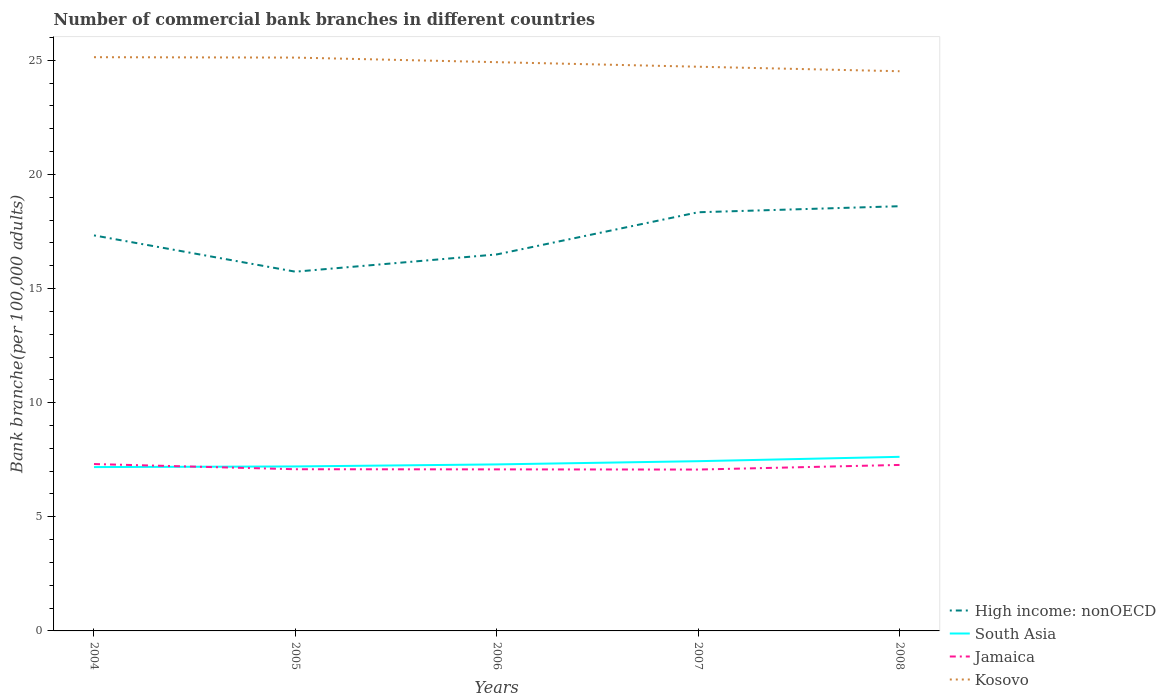Does the line corresponding to Kosovo intersect with the line corresponding to Jamaica?
Offer a terse response. No. Is the number of lines equal to the number of legend labels?
Keep it short and to the point. Yes. Across all years, what is the maximum number of commercial bank branches in High income: nonOECD?
Your answer should be very brief. 15.74. What is the total number of commercial bank branches in South Asia in the graph?
Your answer should be very brief. -0.09. What is the difference between the highest and the second highest number of commercial bank branches in Jamaica?
Keep it short and to the point. 0.24. Is the number of commercial bank branches in Jamaica strictly greater than the number of commercial bank branches in Kosovo over the years?
Provide a succinct answer. Yes. How many lines are there?
Keep it short and to the point. 4. How many years are there in the graph?
Offer a terse response. 5. Does the graph contain any zero values?
Your answer should be compact. No. How many legend labels are there?
Offer a terse response. 4. How are the legend labels stacked?
Ensure brevity in your answer.  Vertical. What is the title of the graph?
Offer a very short reply. Number of commercial bank branches in different countries. Does "Sudan" appear as one of the legend labels in the graph?
Offer a very short reply. No. What is the label or title of the X-axis?
Make the answer very short. Years. What is the label or title of the Y-axis?
Provide a short and direct response. Bank branche(per 100,0 adults). What is the Bank branche(per 100,000 adults) in High income: nonOECD in 2004?
Give a very brief answer. 17.33. What is the Bank branche(per 100,000 adults) in South Asia in 2004?
Offer a very short reply. 7.18. What is the Bank branche(per 100,000 adults) in Jamaica in 2004?
Your answer should be compact. 7.31. What is the Bank branche(per 100,000 adults) in Kosovo in 2004?
Your response must be concise. 25.14. What is the Bank branche(per 100,000 adults) in High income: nonOECD in 2005?
Keep it short and to the point. 15.74. What is the Bank branche(per 100,000 adults) of South Asia in 2005?
Offer a very short reply. 7.21. What is the Bank branche(per 100,000 adults) in Jamaica in 2005?
Make the answer very short. 7.08. What is the Bank branche(per 100,000 adults) of Kosovo in 2005?
Your answer should be compact. 25.12. What is the Bank branche(per 100,000 adults) in High income: nonOECD in 2006?
Ensure brevity in your answer.  16.5. What is the Bank branche(per 100,000 adults) in South Asia in 2006?
Provide a succinct answer. 7.3. What is the Bank branche(per 100,000 adults) in Jamaica in 2006?
Offer a terse response. 7.08. What is the Bank branche(per 100,000 adults) of Kosovo in 2006?
Make the answer very short. 24.92. What is the Bank branche(per 100,000 adults) in High income: nonOECD in 2007?
Keep it short and to the point. 18.34. What is the Bank branche(per 100,000 adults) of South Asia in 2007?
Provide a short and direct response. 7.44. What is the Bank branche(per 100,000 adults) in Jamaica in 2007?
Ensure brevity in your answer.  7.07. What is the Bank branche(per 100,000 adults) in Kosovo in 2007?
Provide a short and direct response. 24.72. What is the Bank branche(per 100,000 adults) in High income: nonOECD in 2008?
Give a very brief answer. 18.61. What is the Bank branche(per 100,000 adults) in South Asia in 2008?
Your answer should be very brief. 7.63. What is the Bank branche(per 100,000 adults) of Jamaica in 2008?
Ensure brevity in your answer.  7.27. What is the Bank branche(per 100,000 adults) in Kosovo in 2008?
Your answer should be compact. 24.52. Across all years, what is the maximum Bank branche(per 100,000 adults) in High income: nonOECD?
Provide a succinct answer. 18.61. Across all years, what is the maximum Bank branche(per 100,000 adults) in South Asia?
Your response must be concise. 7.63. Across all years, what is the maximum Bank branche(per 100,000 adults) of Jamaica?
Provide a short and direct response. 7.31. Across all years, what is the maximum Bank branche(per 100,000 adults) of Kosovo?
Offer a terse response. 25.14. Across all years, what is the minimum Bank branche(per 100,000 adults) of High income: nonOECD?
Make the answer very short. 15.74. Across all years, what is the minimum Bank branche(per 100,000 adults) in South Asia?
Your response must be concise. 7.18. Across all years, what is the minimum Bank branche(per 100,000 adults) of Jamaica?
Ensure brevity in your answer.  7.07. Across all years, what is the minimum Bank branche(per 100,000 adults) of Kosovo?
Keep it short and to the point. 24.52. What is the total Bank branche(per 100,000 adults) of High income: nonOECD in the graph?
Your response must be concise. 86.52. What is the total Bank branche(per 100,000 adults) in South Asia in the graph?
Keep it short and to the point. 36.75. What is the total Bank branche(per 100,000 adults) in Jamaica in the graph?
Give a very brief answer. 35.82. What is the total Bank branche(per 100,000 adults) of Kosovo in the graph?
Your answer should be compact. 124.42. What is the difference between the Bank branche(per 100,000 adults) of High income: nonOECD in 2004 and that in 2005?
Give a very brief answer. 1.59. What is the difference between the Bank branche(per 100,000 adults) of South Asia in 2004 and that in 2005?
Ensure brevity in your answer.  -0.03. What is the difference between the Bank branche(per 100,000 adults) in Jamaica in 2004 and that in 2005?
Your answer should be compact. 0.23. What is the difference between the Bank branche(per 100,000 adults) in Kosovo in 2004 and that in 2005?
Give a very brief answer. 0.02. What is the difference between the Bank branche(per 100,000 adults) in High income: nonOECD in 2004 and that in 2006?
Offer a very short reply. 0.83. What is the difference between the Bank branche(per 100,000 adults) of South Asia in 2004 and that in 2006?
Offer a very short reply. -0.12. What is the difference between the Bank branche(per 100,000 adults) in Jamaica in 2004 and that in 2006?
Ensure brevity in your answer.  0.23. What is the difference between the Bank branche(per 100,000 adults) of Kosovo in 2004 and that in 2006?
Your response must be concise. 0.22. What is the difference between the Bank branche(per 100,000 adults) in High income: nonOECD in 2004 and that in 2007?
Offer a terse response. -1.01. What is the difference between the Bank branche(per 100,000 adults) of South Asia in 2004 and that in 2007?
Offer a very short reply. -0.26. What is the difference between the Bank branche(per 100,000 adults) in Jamaica in 2004 and that in 2007?
Make the answer very short. 0.24. What is the difference between the Bank branche(per 100,000 adults) in Kosovo in 2004 and that in 2007?
Ensure brevity in your answer.  0.42. What is the difference between the Bank branche(per 100,000 adults) of High income: nonOECD in 2004 and that in 2008?
Make the answer very short. -1.28. What is the difference between the Bank branche(per 100,000 adults) in South Asia in 2004 and that in 2008?
Keep it short and to the point. -0.45. What is the difference between the Bank branche(per 100,000 adults) in Jamaica in 2004 and that in 2008?
Offer a terse response. 0.04. What is the difference between the Bank branche(per 100,000 adults) in Kosovo in 2004 and that in 2008?
Ensure brevity in your answer.  0.62. What is the difference between the Bank branche(per 100,000 adults) of High income: nonOECD in 2005 and that in 2006?
Provide a succinct answer. -0.76. What is the difference between the Bank branche(per 100,000 adults) in South Asia in 2005 and that in 2006?
Give a very brief answer. -0.09. What is the difference between the Bank branche(per 100,000 adults) of Jamaica in 2005 and that in 2006?
Provide a succinct answer. 0.01. What is the difference between the Bank branche(per 100,000 adults) in Kosovo in 2005 and that in 2006?
Your response must be concise. 0.2. What is the difference between the Bank branche(per 100,000 adults) in High income: nonOECD in 2005 and that in 2007?
Offer a very short reply. -2.6. What is the difference between the Bank branche(per 100,000 adults) in South Asia in 2005 and that in 2007?
Offer a terse response. -0.23. What is the difference between the Bank branche(per 100,000 adults) of Jamaica in 2005 and that in 2007?
Make the answer very short. 0.01. What is the difference between the Bank branche(per 100,000 adults) in Kosovo in 2005 and that in 2007?
Keep it short and to the point. 0.4. What is the difference between the Bank branche(per 100,000 adults) of High income: nonOECD in 2005 and that in 2008?
Provide a short and direct response. -2.87. What is the difference between the Bank branche(per 100,000 adults) of South Asia in 2005 and that in 2008?
Ensure brevity in your answer.  -0.42. What is the difference between the Bank branche(per 100,000 adults) of Jamaica in 2005 and that in 2008?
Your answer should be compact. -0.19. What is the difference between the Bank branche(per 100,000 adults) in Kosovo in 2005 and that in 2008?
Your answer should be compact. 0.6. What is the difference between the Bank branche(per 100,000 adults) in High income: nonOECD in 2006 and that in 2007?
Your response must be concise. -1.85. What is the difference between the Bank branche(per 100,000 adults) in South Asia in 2006 and that in 2007?
Your answer should be compact. -0.14. What is the difference between the Bank branche(per 100,000 adults) of Jamaica in 2006 and that in 2007?
Ensure brevity in your answer.  0.01. What is the difference between the Bank branche(per 100,000 adults) in Kosovo in 2006 and that in 2007?
Make the answer very short. 0.2. What is the difference between the Bank branche(per 100,000 adults) of High income: nonOECD in 2006 and that in 2008?
Offer a terse response. -2.11. What is the difference between the Bank branche(per 100,000 adults) in South Asia in 2006 and that in 2008?
Your answer should be compact. -0.33. What is the difference between the Bank branche(per 100,000 adults) in Jamaica in 2006 and that in 2008?
Ensure brevity in your answer.  -0.19. What is the difference between the Bank branche(per 100,000 adults) in Kosovo in 2006 and that in 2008?
Your answer should be compact. 0.4. What is the difference between the Bank branche(per 100,000 adults) in High income: nonOECD in 2007 and that in 2008?
Make the answer very short. -0.26. What is the difference between the Bank branche(per 100,000 adults) of South Asia in 2007 and that in 2008?
Offer a terse response. -0.19. What is the difference between the Bank branche(per 100,000 adults) of Jamaica in 2007 and that in 2008?
Your answer should be very brief. -0.2. What is the difference between the Bank branche(per 100,000 adults) of Kosovo in 2007 and that in 2008?
Your answer should be very brief. 0.2. What is the difference between the Bank branche(per 100,000 adults) of High income: nonOECD in 2004 and the Bank branche(per 100,000 adults) of South Asia in 2005?
Provide a succinct answer. 10.12. What is the difference between the Bank branche(per 100,000 adults) in High income: nonOECD in 2004 and the Bank branche(per 100,000 adults) in Jamaica in 2005?
Your answer should be compact. 10.25. What is the difference between the Bank branche(per 100,000 adults) of High income: nonOECD in 2004 and the Bank branche(per 100,000 adults) of Kosovo in 2005?
Keep it short and to the point. -7.79. What is the difference between the Bank branche(per 100,000 adults) in South Asia in 2004 and the Bank branche(per 100,000 adults) in Jamaica in 2005?
Make the answer very short. 0.09. What is the difference between the Bank branche(per 100,000 adults) of South Asia in 2004 and the Bank branche(per 100,000 adults) of Kosovo in 2005?
Keep it short and to the point. -17.94. What is the difference between the Bank branche(per 100,000 adults) of Jamaica in 2004 and the Bank branche(per 100,000 adults) of Kosovo in 2005?
Provide a short and direct response. -17.81. What is the difference between the Bank branche(per 100,000 adults) in High income: nonOECD in 2004 and the Bank branche(per 100,000 adults) in South Asia in 2006?
Offer a terse response. 10.03. What is the difference between the Bank branche(per 100,000 adults) in High income: nonOECD in 2004 and the Bank branche(per 100,000 adults) in Jamaica in 2006?
Offer a very short reply. 10.25. What is the difference between the Bank branche(per 100,000 adults) in High income: nonOECD in 2004 and the Bank branche(per 100,000 adults) in Kosovo in 2006?
Provide a succinct answer. -7.59. What is the difference between the Bank branche(per 100,000 adults) of South Asia in 2004 and the Bank branche(per 100,000 adults) of Jamaica in 2006?
Ensure brevity in your answer.  0.1. What is the difference between the Bank branche(per 100,000 adults) of South Asia in 2004 and the Bank branche(per 100,000 adults) of Kosovo in 2006?
Provide a succinct answer. -17.74. What is the difference between the Bank branche(per 100,000 adults) of Jamaica in 2004 and the Bank branche(per 100,000 adults) of Kosovo in 2006?
Provide a short and direct response. -17.61. What is the difference between the Bank branche(per 100,000 adults) in High income: nonOECD in 2004 and the Bank branche(per 100,000 adults) in South Asia in 2007?
Your answer should be compact. 9.89. What is the difference between the Bank branche(per 100,000 adults) in High income: nonOECD in 2004 and the Bank branche(per 100,000 adults) in Jamaica in 2007?
Offer a very short reply. 10.26. What is the difference between the Bank branche(per 100,000 adults) in High income: nonOECD in 2004 and the Bank branche(per 100,000 adults) in Kosovo in 2007?
Your response must be concise. -7.39. What is the difference between the Bank branche(per 100,000 adults) in South Asia in 2004 and the Bank branche(per 100,000 adults) in Jamaica in 2007?
Your answer should be compact. 0.11. What is the difference between the Bank branche(per 100,000 adults) of South Asia in 2004 and the Bank branche(per 100,000 adults) of Kosovo in 2007?
Provide a short and direct response. -17.54. What is the difference between the Bank branche(per 100,000 adults) of Jamaica in 2004 and the Bank branche(per 100,000 adults) of Kosovo in 2007?
Provide a succinct answer. -17.41. What is the difference between the Bank branche(per 100,000 adults) of High income: nonOECD in 2004 and the Bank branche(per 100,000 adults) of South Asia in 2008?
Your response must be concise. 9.7. What is the difference between the Bank branche(per 100,000 adults) in High income: nonOECD in 2004 and the Bank branche(per 100,000 adults) in Jamaica in 2008?
Provide a succinct answer. 10.06. What is the difference between the Bank branche(per 100,000 adults) in High income: nonOECD in 2004 and the Bank branche(per 100,000 adults) in Kosovo in 2008?
Your answer should be very brief. -7.19. What is the difference between the Bank branche(per 100,000 adults) in South Asia in 2004 and the Bank branche(per 100,000 adults) in Jamaica in 2008?
Give a very brief answer. -0.09. What is the difference between the Bank branche(per 100,000 adults) in South Asia in 2004 and the Bank branche(per 100,000 adults) in Kosovo in 2008?
Your answer should be compact. -17.34. What is the difference between the Bank branche(per 100,000 adults) of Jamaica in 2004 and the Bank branche(per 100,000 adults) of Kosovo in 2008?
Give a very brief answer. -17.21. What is the difference between the Bank branche(per 100,000 adults) of High income: nonOECD in 2005 and the Bank branche(per 100,000 adults) of South Asia in 2006?
Offer a very short reply. 8.44. What is the difference between the Bank branche(per 100,000 adults) in High income: nonOECD in 2005 and the Bank branche(per 100,000 adults) in Jamaica in 2006?
Keep it short and to the point. 8.66. What is the difference between the Bank branche(per 100,000 adults) of High income: nonOECD in 2005 and the Bank branche(per 100,000 adults) of Kosovo in 2006?
Offer a very short reply. -9.18. What is the difference between the Bank branche(per 100,000 adults) of South Asia in 2005 and the Bank branche(per 100,000 adults) of Jamaica in 2006?
Your answer should be very brief. 0.13. What is the difference between the Bank branche(per 100,000 adults) in South Asia in 2005 and the Bank branche(per 100,000 adults) in Kosovo in 2006?
Ensure brevity in your answer.  -17.71. What is the difference between the Bank branche(per 100,000 adults) of Jamaica in 2005 and the Bank branche(per 100,000 adults) of Kosovo in 2006?
Your answer should be compact. -17.84. What is the difference between the Bank branche(per 100,000 adults) of High income: nonOECD in 2005 and the Bank branche(per 100,000 adults) of South Asia in 2007?
Offer a terse response. 8.3. What is the difference between the Bank branche(per 100,000 adults) in High income: nonOECD in 2005 and the Bank branche(per 100,000 adults) in Jamaica in 2007?
Your answer should be very brief. 8.67. What is the difference between the Bank branche(per 100,000 adults) of High income: nonOECD in 2005 and the Bank branche(per 100,000 adults) of Kosovo in 2007?
Keep it short and to the point. -8.98. What is the difference between the Bank branche(per 100,000 adults) of South Asia in 2005 and the Bank branche(per 100,000 adults) of Jamaica in 2007?
Keep it short and to the point. 0.14. What is the difference between the Bank branche(per 100,000 adults) of South Asia in 2005 and the Bank branche(per 100,000 adults) of Kosovo in 2007?
Give a very brief answer. -17.51. What is the difference between the Bank branche(per 100,000 adults) of Jamaica in 2005 and the Bank branche(per 100,000 adults) of Kosovo in 2007?
Ensure brevity in your answer.  -17.64. What is the difference between the Bank branche(per 100,000 adults) in High income: nonOECD in 2005 and the Bank branche(per 100,000 adults) in South Asia in 2008?
Your response must be concise. 8.11. What is the difference between the Bank branche(per 100,000 adults) in High income: nonOECD in 2005 and the Bank branche(per 100,000 adults) in Jamaica in 2008?
Offer a terse response. 8.47. What is the difference between the Bank branche(per 100,000 adults) in High income: nonOECD in 2005 and the Bank branche(per 100,000 adults) in Kosovo in 2008?
Give a very brief answer. -8.78. What is the difference between the Bank branche(per 100,000 adults) of South Asia in 2005 and the Bank branche(per 100,000 adults) of Jamaica in 2008?
Offer a very short reply. -0.07. What is the difference between the Bank branche(per 100,000 adults) of South Asia in 2005 and the Bank branche(per 100,000 adults) of Kosovo in 2008?
Give a very brief answer. -17.32. What is the difference between the Bank branche(per 100,000 adults) of Jamaica in 2005 and the Bank branche(per 100,000 adults) of Kosovo in 2008?
Your answer should be compact. -17.44. What is the difference between the Bank branche(per 100,000 adults) in High income: nonOECD in 2006 and the Bank branche(per 100,000 adults) in South Asia in 2007?
Your answer should be very brief. 9.06. What is the difference between the Bank branche(per 100,000 adults) in High income: nonOECD in 2006 and the Bank branche(per 100,000 adults) in Jamaica in 2007?
Provide a succinct answer. 9.43. What is the difference between the Bank branche(per 100,000 adults) of High income: nonOECD in 2006 and the Bank branche(per 100,000 adults) of Kosovo in 2007?
Your answer should be very brief. -8.22. What is the difference between the Bank branche(per 100,000 adults) in South Asia in 2006 and the Bank branche(per 100,000 adults) in Jamaica in 2007?
Your answer should be very brief. 0.23. What is the difference between the Bank branche(per 100,000 adults) in South Asia in 2006 and the Bank branche(per 100,000 adults) in Kosovo in 2007?
Provide a succinct answer. -17.42. What is the difference between the Bank branche(per 100,000 adults) of Jamaica in 2006 and the Bank branche(per 100,000 adults) of Kosovo in 2007?
Ensure brevity in your answer.  -17.64. What is the difference between the Bank branche(per 100,000 adults) of High income: nonOECD in 2006 and the Bank branche(per 100,000 adults) of South Asia in 2008?
Offer a terse response. 8.87. What is the difference between the Bank branche(per 100,000 adults) of High income: nonOECD in 2006 and the Bank branche(per 100,000 adults) of Jamaica in 2008?
Provide a short and direct response. 9.22. What is the difference between the Bank branche(per 100,000 adults) of High income: nonOECD in 2006 and the Bank branche(per 100,000 adults) of Kosovo in 2008?
Your answer should be compact. -8.03. What is the difference between the Bank branche(per 100,000 adults) in South Asia in 2006 and the Bank branche(per 100,000 adults) in Jamaica in 2008?
Ensure brevity in your answer.  0.02. What is the difference between the Bank branche(per 100,000 adults) of South Asia in 2006 and the Bank branche(per 100,000 adults) of Kosovo in 2008?
Offer a very short reply. -17.23. What is the difference between the Bank branche(per 100,000 adults) of Jamaica in 2006 and the Bank branche(per 100,000 adults) of Kosovo in 2008?
Your answer should be very brief. -17.44. What is the difference between the Bank branche(per 100,000 adults) of High income: nonOECD in 2007 and the Bank branche(per 100,000 adults) of South Asia in 2008?
Provide a short and direct response. 10.72. What is the difference between the Bank branche(per 100,000 adults) of High income: nonOECD in 2007 and the Bank branche(per 100,000 adults) of Jamaica in 2008?
Your answer should be very brief. 11.07. What is the difference between the Bank branche(per 100,000 adults) of High income: nonOECD in 2007 and the Bank branche(per 100,000 adults) of Kosovo in 2008?
Ensure brevity in your answer.  -6.18. What is the difference between the Bank branche(per 100,000 adults) of South Asia in 2007 and the Bank branche(per 100,000 adults) of Jamaica in 2008?
Ensure brevity in your answer.  0.16. What is the difference between the Bank branche(per 100,000 adults) of South Asia in 2007 and the Bank branche(per 100,000 adults) of Kosovo in 2008?
Provide a short and direct response. -17.09. What is the difference between the Bank branche(per 100,000 adults) of Jamaica in 2007 and the Bank branche(per 100,000 adults) of Kosovo in 2008?
Ensure brevity in your answer.  -17.45. What is the average Bank branche(per 100,000 adults) of High income: nonOECD per year?
Your response must be concise. 17.3. What is the average Bank branche(per 100,000 adults) of South Asia per year?
Ensure brevity in your answer.  7.35. What is the average Bank branche(per 100,000 adults) of Jamaica per year?
Offer a very short reply. 7.16. What is the average Bank branche(per 100,000 adults) of Kosovo per year?
Your answer should be compact. 24.88. In the year 2004, what is the difference between the Bank branche(per 100,000 adults) in High income: nonOECD and Bank branche(per 100,000 adults) in South Asia?
Provide a succinct answer. 10.15. In the year 2004, what is the difference between the Bank branche(per 100,000 adults) of High income: nonOECD and Bank branche(per 100,000 adults) of Jamaica?
Your answer should be compact. 10.02. In the year 2004, what is the difference between the Bank branche(per 100,000 adults) of High income: nonOECD and Bank branche(per 100,000 adults) of Kosovo?
Provide a short and direct response. -7.81. In the year 2004, what is the difference between the Bank branche(per 100,000 adults) of South Asia and Bank branche(per 100,000 adults) of Jamaica?
Ensure brevity in your answer.  -0.13. In the year 2004, what is the difference between the Bank branche(per 100,000 adults) in South Asia and Bank branche(per 100,000 adults) in Kosovo?
Provide a succinct answer. -17.96. In the year 2004, what is the difference between the Bank branche(per 100,000 adults) of Jamaica and Bank branche(per 100,000 adults) of Kosovo?
Ensure brevity in your answer.  -17.83. In the year 2005, what is the difference between the Bank branche(per 100,000 adults) in High income: nonOECD and Bank branche(per 100,000 adults) in South Asia?
Provide a short and direct response. 8.53. In the year 2005, what is the difference between the Bank branche(per 100,000 adults) of High income: nonOECD and Bank branche(per 100,000 adults) of Jamaica?
Your answer should be very brief. 8.66. In the year 2005, what is the difference between the Bank branche(per 100,000 adults) of High income: nonOECD and Bank branche(per 100,000 adults) of Kosovo?
Your answer should be compact. -9.38. In the year 2005, what is the difference between the Bank branche(per 100,000 adults) in South Asia and Bank branche(per 100,000 adults) in Jamaica?
Make the answer very short. 0.12. In the year 2005, what is the difference between the Bank branche(per 100,000 adults) in South Asia and Bank branche(per 100,000 adults) in Kosovo?
Your answer should be very brief. -17.91. In the year 2005, what is the difference between the Bank branche(per 100,000 adults) in Jamaica and Bank branche(per 100,000 adults) in Kosovo?
Offer a terse response. -18.04. In the year 2006, what is the difference between the Bank branche(per 100,000 adults) of High income: nonOECD and Bank branche(per 100,000 adults) of South Asia?
Offer a terse response. 9.2. In the year 2006, what is the difference between the Bank branche(per 100,000 adults) of High income: nonOECD and Bank branche(per 100,000 adults) of Jamaica?
Provide a short and direct response. 9.42. In the year 2006, what is the difference between the Bank branche(per 100,000 adults) of High income: nonOECD and Bank branche(per 100,000 adults) of Kosovo?
Make the answer very short. -8.42. In the year 2006, what is the difference between the Bank branche(per 100,000 adults) of South Asia and Bank branche(per 100,000 adults) of Jamaica?
Provide a succinct answer. 0.22. In the year 2006, what is the difference between the Bank branche(per 100,000 adults) in South Asia and Bank branche(per 100,000 adults) in Kosovo?
Make the answer very short. -17.62. In the year 2006, what is the difference between the Bank branche(per 100,000 adults) in Jamaica and Bank branche(per 100,000 adults) in Kosovo?
Ensure brevity in your answer.  -17.84. In the year 2007, what is the difference between the Bank branche(per 100,000 adults) of High income: nonOECD and Bank branche(per 100,000 adults) of South Asia?
Offer a very short reply. 10.91. In the year 2007, what is the difference between the Bank branche(per 100,000 adults) in High income: nonOECD and Bank branche(per 100,000 adults) in Jamaica?
Give a very brief answer. 11.27. In the year 2007, what is the difference between the Bank branche(per 100,000 adults) of High income: nonOECD and Bank branche(per 100,000 adults) of Kosovo?
Keep it short and to the point. -6.38. In the year 2007, what is the difference between the Bank branche(per 100,000 adults) in South Asia and Bank branche(per 100,000 adults) in Jamaica?
Offer a terse response. 0.37. In the year 2007, what is the difference between the Bank branche(per 100,000 adults) in South Asia and Bank branche(per 100,000 adults) in Kosovo?
Provide a short and direct response. -17.28. In the year 2007, what is the difference between the Bank branche(per 100,000 adults) of Jamaica and Bank branche(per 100,000 adults) of Kosovo?
Your response must be concise. -17.65. In the year 2008, what is the difference between the Bank branche(per 100,000 adults) of High income: nonOECD and Bank branche(per 100,000 adults) of South Asia?
Make the answer very short. 10.98. In the year 2008, what is the difference between the Bank branche(per 100,000 adults) of High income: nonOECD and Bank branche(per 100,000 adults) of Jamaica?
Give a very brief answer. 11.34. In the year 2008, what is the difference between the Bank branche(per 100,000 adults) in High income: nonOECD and Bank branche(per 100,000 adults) in Kosovo?
Provide a succinct answer. -5.91. In the year 2008, what is the difference between the Bank branche(per 100,000 adults) in South Asia and Bank branche(per 100,000 adults) in Jamaica?
Your answer should be very brief. 0.36. In the year 2008, what is the difference between the Bank branche(per 100,000 adults) of South Asia and Bank branche(per 100,000 adults) of Kosovo?
Your response must be concise. -16.89. In the year 2008, what is the difference between the Bank branche(per 100,000 adults) in Jamaica and Bank branche(per 100,000 adults) in Kosovo?
Offer a very short reply. -17.25. What is the ratio of the Bank branche(per 100,000 adults) in High income: nonOECD in 2004 to that in 2005?
Provide a short and direct response. 1.1. What is the ratio of the Bank branche(per 100,000 adults) of Jamaica in 2004 to that in 2005?
Provide a short and direct response. 1.03. What is the ratio of the Bank branche(per 100,000 adults) in High income: nonOECD in 2004 to that in 2006?
Keep it short and to the point. 1.05. What is the ratio of the Bank branche(per 100,000 adults) of South Asia in 2004 to that in 2006?
Make the answer very short. 0.98. What is the ratio of the Bank branche(per 100,000 adults) in Jamaica in 2004 to that in 2006?
Make the answer very short. 1.03. What is the ratio of the Bank branche(per 100,000 adults) in Kosovo in 2004 to that in 2006?
Make the answer very short. 1.01. What is the ratio of the Bank branche(per 100,000 adults) of High income: nonOECD in 2004 to that in 2007?
Keep it short and to the point. 0.94. What is the ratio of the Bank branche(per 100,000 adults) of South Asia in 2004 to that in 2007?
Ensure brevity in your answer.  0.97. What is the ratio of the Bank branche(per 100,000 adults) of Jamaica in 2004 to that in 2007?
Provide a succinct answer. 1.03. What is the ratio of the Bank branche(per 100,000 adults) of Kosovo in 2004 to that in 2007?
Make the answer very short. 1.02. What is the ratio of the Bank branche(per 100,000 adults) of High income: nonOECD in 2004 to that in 2008?
Provide a short and direct response. 0.93. What is the ratio of the Bank branche(per 100,000 adults) of South Asia in 2004 to that in 2008?
Your answer should be very brief. 0.94. What is the ratio of the Bank branche(per 100,000 adults) in Jamaica in 2004 to that in 2008?
Your answer should be compact. 1.01. What is the ratio of the Bank branche(per 100,000 adults) in Kosovo in 2004 to that in 2008?
Provide a short and direct response. 1.03. What is the ratio of the Bank branche(per 100,000 adults) of High income: nonOECD in 2005 to that in 2006?
Your answer should be very brief. 0.95. What is the ratio of the Bank branche(per 100,000 adults) of South Asia in 2005 to that in 2006?
Provide a succinct answer. 0.99. What is the ratio of the Bank branche(per 100,000 adults) in High income: nonOECD in 2005 to that in 2007?
Ensure brevity in your answer.  0.86. What is the ratio of the Bank branche(per 100,000 adults) of South Asia in 2005 to that in 2007?
Your answer should be compact. 0.97. What is the ratio of the Bank branche(per 100,000 adults) in Jamaica in 2005 to that in 2007?
Provide a succinct answer. 1. What is the ratio of the Bank branche(per 100,000 adults) of Kosovo in 2005 to that in 2007?
Offer a terse response. 1.02. What is the ratio of the Bank branche(per 100,000 adults) of High income: nonOECD in 2005 to that in 2008?
Provide a succinct answer. 0.85. What is the ratio of the Bank branche(per 100,000 adults) in South Asia in 2005 to that in 2008?
Provide a short and direct response. 0.94. What is the ratio of the Bank branche(per 100,000 adults) in Jamaica in 2005 to that in 2008?
Your answer should be very brief. 0.97. What is the ratio of the Bank branche(per 100,000 adults) in Kosovo in 2005 to that in 2008?
Your answer should be compact. 1.02. What is the ratio of the Bank branche(per 100,000 adults) in High income: nonOECD in 2006 to that in 2007?
Ensure brevity in your answer.  0.9. What is the ratio of the Bank branche(per 100,000 adults) of High income: nonOECD in 2006 to that in 2008?
Your response must be concise. 0.89. What is the ratio of the Bank branche(per 100,000 adults) of South Asia in 2006 to that in 2008?
Your response must be concise. 0.96. What is the ratio of the Bank branche(per 100,000 adults) in Jamaica in 2006 to that in 2008?
Provide a succinct answer. 0.97. What is the ratio of the Bank branche(per 100,000 adults) in Kosovo in 2006 to that in 2008?
Give a very brief answer. 1.02. What is the ratio of the Bank branche(per 100,000 adults) of High income: nonOECD in 2007 to that in 2008?
Your response must be concise. 0.99. What is the ratio of the Bank branche(per 100,000 adults) of Jamaica in 2007 to that in 2008?
Keep it short and to the point. 0.97. What is the ratio of the Bank branche(per 100,000 adults) in Kosovo in 2007 to that in 2008?
Offer a terse response. 1.01. What is the difference between the highest and the second highest Bank branche(per 100,000 adults) of High income: nonOECD?
Provide a short and direct response. 0.26. What is the difference between the highest and the second highest Bank branche(per 100,000 adults) of South Asia?
Your answer should be very brief. 0.19. What is the difference between the highest and the second highest Bank branche(per 100,000 adults) of Jamaica?
Offer a very short reply. 0.04. What is the difference between the highest and the second highest Bank branche(per 100,000 adults) in Kosovo?
Offer a terse response. 0.02. What is the difference between the highest and the lowest Bank branche(per 100,000 adults) in High income: nonOECD?
Give a very brief answer. 2.87. What is the difference between the highest and the lowest Bank branche(per 100,000 adults) in South Asia?
Make the answer very short. 0.45. What is the difference between the highest and the lowest Bank branche(per 100,000 adults) of Jamaica?
Offer a very short reply. 0.24. What is the difference between the highest and the lowest Bank branche(per 100,000 adults) of Kosovo?
Your answer should be compact. 0.62. 